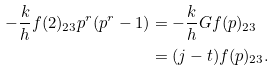<formula> <loc_0><loc_0><loc_500><loc_500>- \frac { k } { h } f ( 2 ) _ { 2 3 } p ^ { r } ( p ^ { r } - 1 ) & = - \frac { k } { h } G f ( p ) _ { 2 3 } \\ & = ( j - t ) f ( p ) _ { 2 3 } .</formula> 